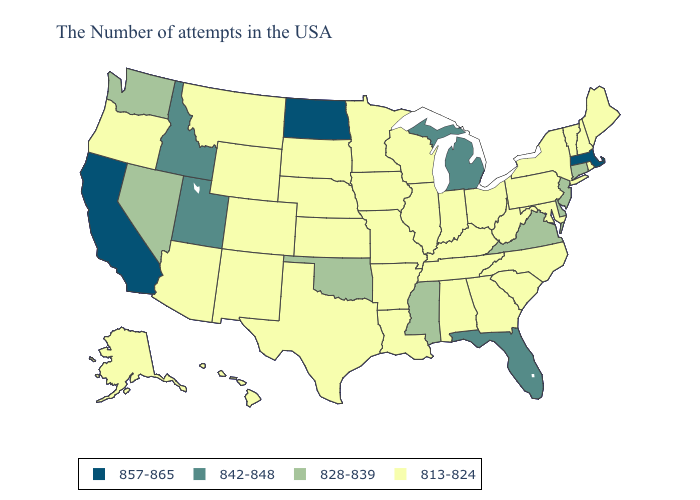Name the states that have a value in the range 842-848?
Short answer required. Florida, Michigan, Utah, Idaho. Does the first symbol in the legend represent the smallest category?
Keep it brief. No. Name the states that have a value in the range 828-839?
Give a very brief answer. Connecticut, New Jersey, Delaware, Virginia, Mississippi, Oklahoma, Nevada, Washington. Does Utah have the lowest value in the USA?
Quick response, please. No. Is the legend a continuous bar?
Be succinct. No. Is the legend a continuous bar?
Short answer required. No. Name the states that have a value in the range 842-848?
Quick response, please. Florida, Michigan, Utah, Idaho. Among the states that border North Carolina , does Virginia have the highest value?
Quick response, please. Yes. Name the states that have a value in the range 857-865?
Keep it brief. Massachusetts, North Dakota, California. Name the states that have a value in the range 813-824?
Be succinct. Maine, Rhode Island, New Hampshire, Vermont, New York, Maryland, Pennsylvania, North Carolina, South Carolina, West Virginia, Ohio, Georgia, Kentucky, Indiana, Alabama, Tennessee, Wisconsin, Illinois, Louisiana, Missouri, Arkansas, Minnesota, Iowa, Kansas, Nebraska, Texas, South Dakota, Wyoming, Colorado, New Mexico, Montana, Arizona, Oregon, Alaska, Hawaii. What is the lowest value in states that border Vermont?
Answer briefly. 813-824. What is the lowest value in states that border Arizona?
Quick response, please. 813-824. Which states have the highest value in the USA?
Concise answer only. Massachusetts, North Dakota, California. 